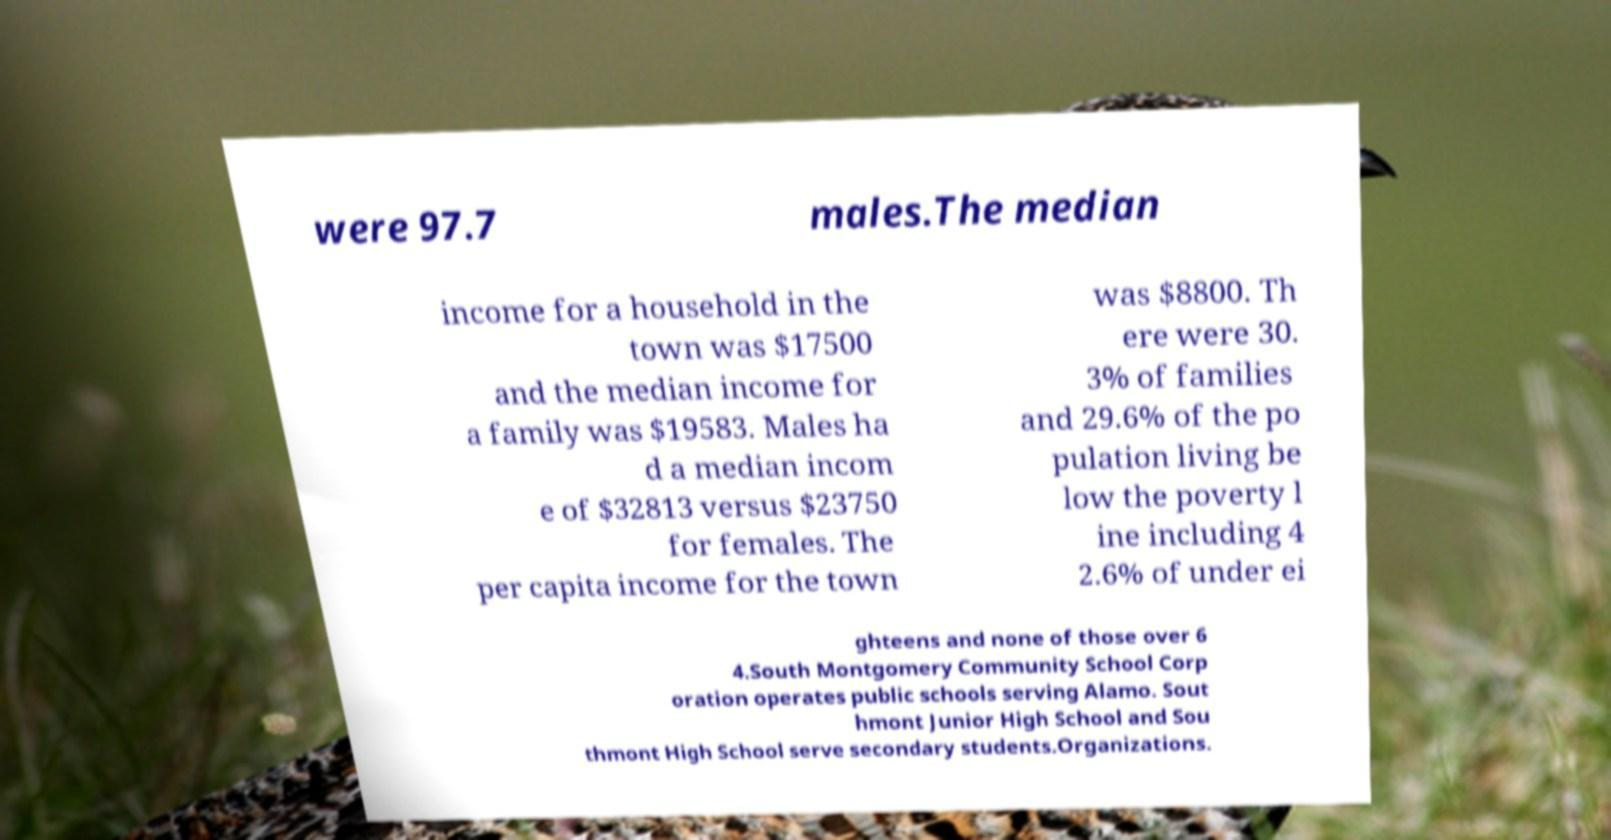Please read and relay the text visible in this image. What does it say? were 97.7 males.The median income for a household in the town was $17500 and the median income for a family was $19583. Males ha d a median incom e of $32813 versus $23750 for females. The per capita income for the town was $8800. Th ere were 30. 3% of families and 29.6% of the po pulation living be low the poverty l ine including 4 2.6% of under ei ghteens and none of those over 6 4.South Montgomery Community School Corp oration operates public schools serving Alamo. Sout hmont Junior High School and Sou thmont High School serve secondary students.Organizations. 